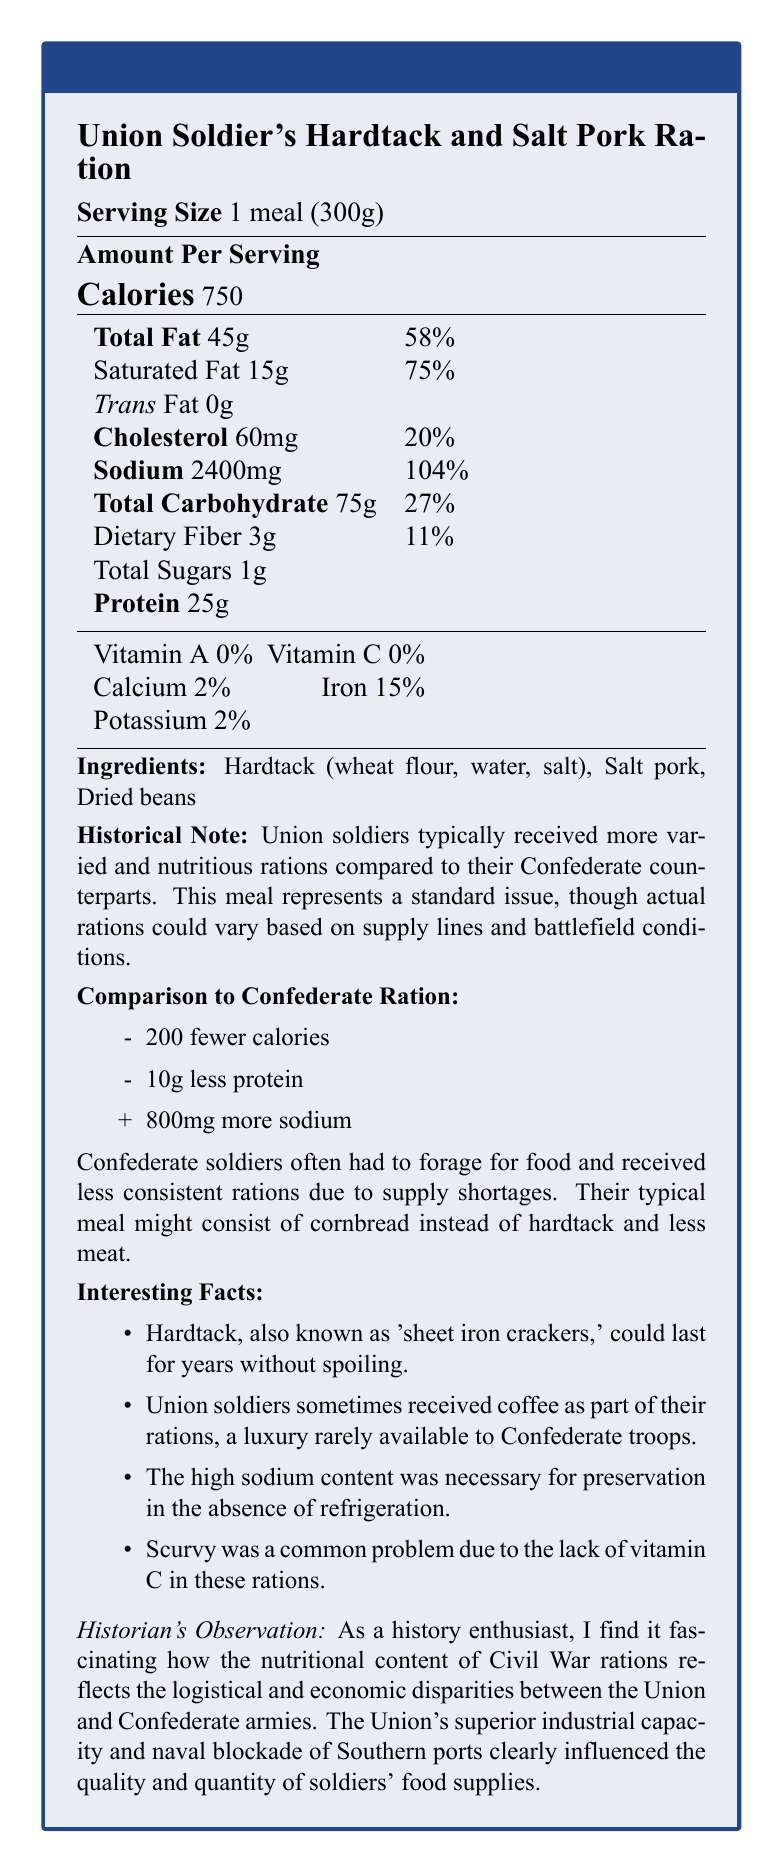what is the serving size for the ration? The serving size is clearly stated at the beginning of the document as "1 meal (300g)."
Answer: 1 meal (300g) how many calories are in one serving of the Union Soldier's Hardtack and Salt Pork Ration? The calories per serving are listed as 750.
Answer: 750 how much sodium does one serving contain? The amount of sodium per serving is listed as 2400mg, which is 104% of the daily value.
Answer: 2400mg what are the three main ingredients in the ration? The main ingredients are listed near the end of the document.
Answer: Hardtack (wheat flour, water, salt), Salt pork, Dried beans why was high sodium content necessary in these rations? One of the interesting facts mentions that the high sodium content was necessary for preservation as there was no refrigeration.
Answer: For preservation in the absence of refrigeration how does the protein content of the Union ration compare to the Confederate ration? The document states that the Union ration has 10g more protein than the Confederate ration.
Answer: The Union ration has 10g more protein what was a luxury item sometimes included in Union rations but rarely available to Confederate troops? The interesting facts section mentions that Union soldiers sometimes received coffee, a luxury rarely available to Confederate troops.
Answer: Coffee what percentage of the daily value for saturated fat does one serving of the ration provide? One serving provides 75% of the daily value for saturated fat.
Answer: 75% what were some common problems due to the lack of certain vitamins in rations? The interesting facts section mentions that scurvy was a common problem due to the lack of vitamin C in the rations.
Answer: Scurvy due to lack of vitamin C how many calories less are in a Confederate ration compared to a Union ration? A) 100 B) 200 C) 300 D) 400 The comparison to Confederate rations section states that the Confederate ration had 200 fewer calories.
Answer: B) 200 which nutrient is provided at 0% of the daily value in the ration? A) Vitamin A B) Calcium C) Iron D) Potassium The percentages for Vitamin A and Vitamin C are both 0%, but since one option is Vitamin A, it is the correct one.
Answer: A) Vitamin A are dietary fiber amounts in the Union Soldier's ration sufficient for a balanced diet? (Yes/No) The ration provides only 11% of the daily value for dietary fiber.
Answer: No summarize the main idea of the document. The main idea of the document is to illustrate the nutritional content of a typical Union soldier's meal during the Civil War, highlighting the differences from Confederate rations and providing some historical context and interesting details about the food.
Answer: The document provides the nutritional facts of a Union Soldier's Hardtack and Salt Pork Ration during the American Civil War. It highlights the differences in rations between Union and Confederate soldiers, emphasizing that Union soldiers received more varied and nutritious rations. The document mentions the ingredients and compares the nutritional values, also noting some historical context and interesting facts about the food. what was the total production cost of the Union ration? There is no information provided in the document about the production cost of the Union ration.
Answer: Cannot be determined 